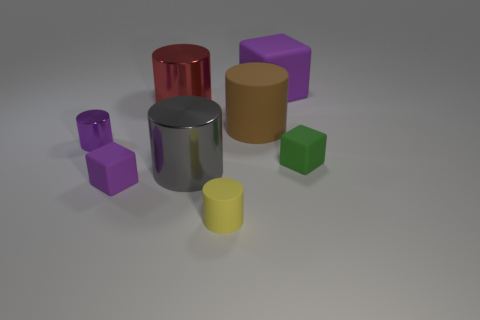Is the number of large brown cylinders to the right of the large brown cylinder greater than the number of yellow matte cylinders on the right side of the tiny green rubber thing?
Your response must be concise. No. There is a small metal cylinder; are there any brown objects in front of it?
Give a very brief answer. No. What is the material of the big object that is both behind the large rubber cylinder and to the left of the brown matte cylinder?
Your answer should be compact. Metal. There is a large matte object that is the same shape as the small yellow rubber object; what is its color?
Provide a short and direct response. Brown. There is a big metallic thing that is in front of the big red shiny cylinder; is there a large cylinder on the left side of it?
Give a very brief answer. Yes. The purple metallic cylinder is what size?
Your response must be concise. Small. There is a rubber thing that is both right of the brown matte thing and on the left side of the tiny green cube; what is its shape?
Offer a terse response. Cube. How many purple objects are either rubber objects or big cylinders?
Ensure brevity in your answer.  2. There is a purple cube that is in front of the gray metallic cylinder; does it have the same size as the shiny cylinder right of the big red cylinder?
Provide a succinct answer. No. What number of things are either large red rubber objects or tiny purple shiny things?
Provide a short and direct response. 1. 